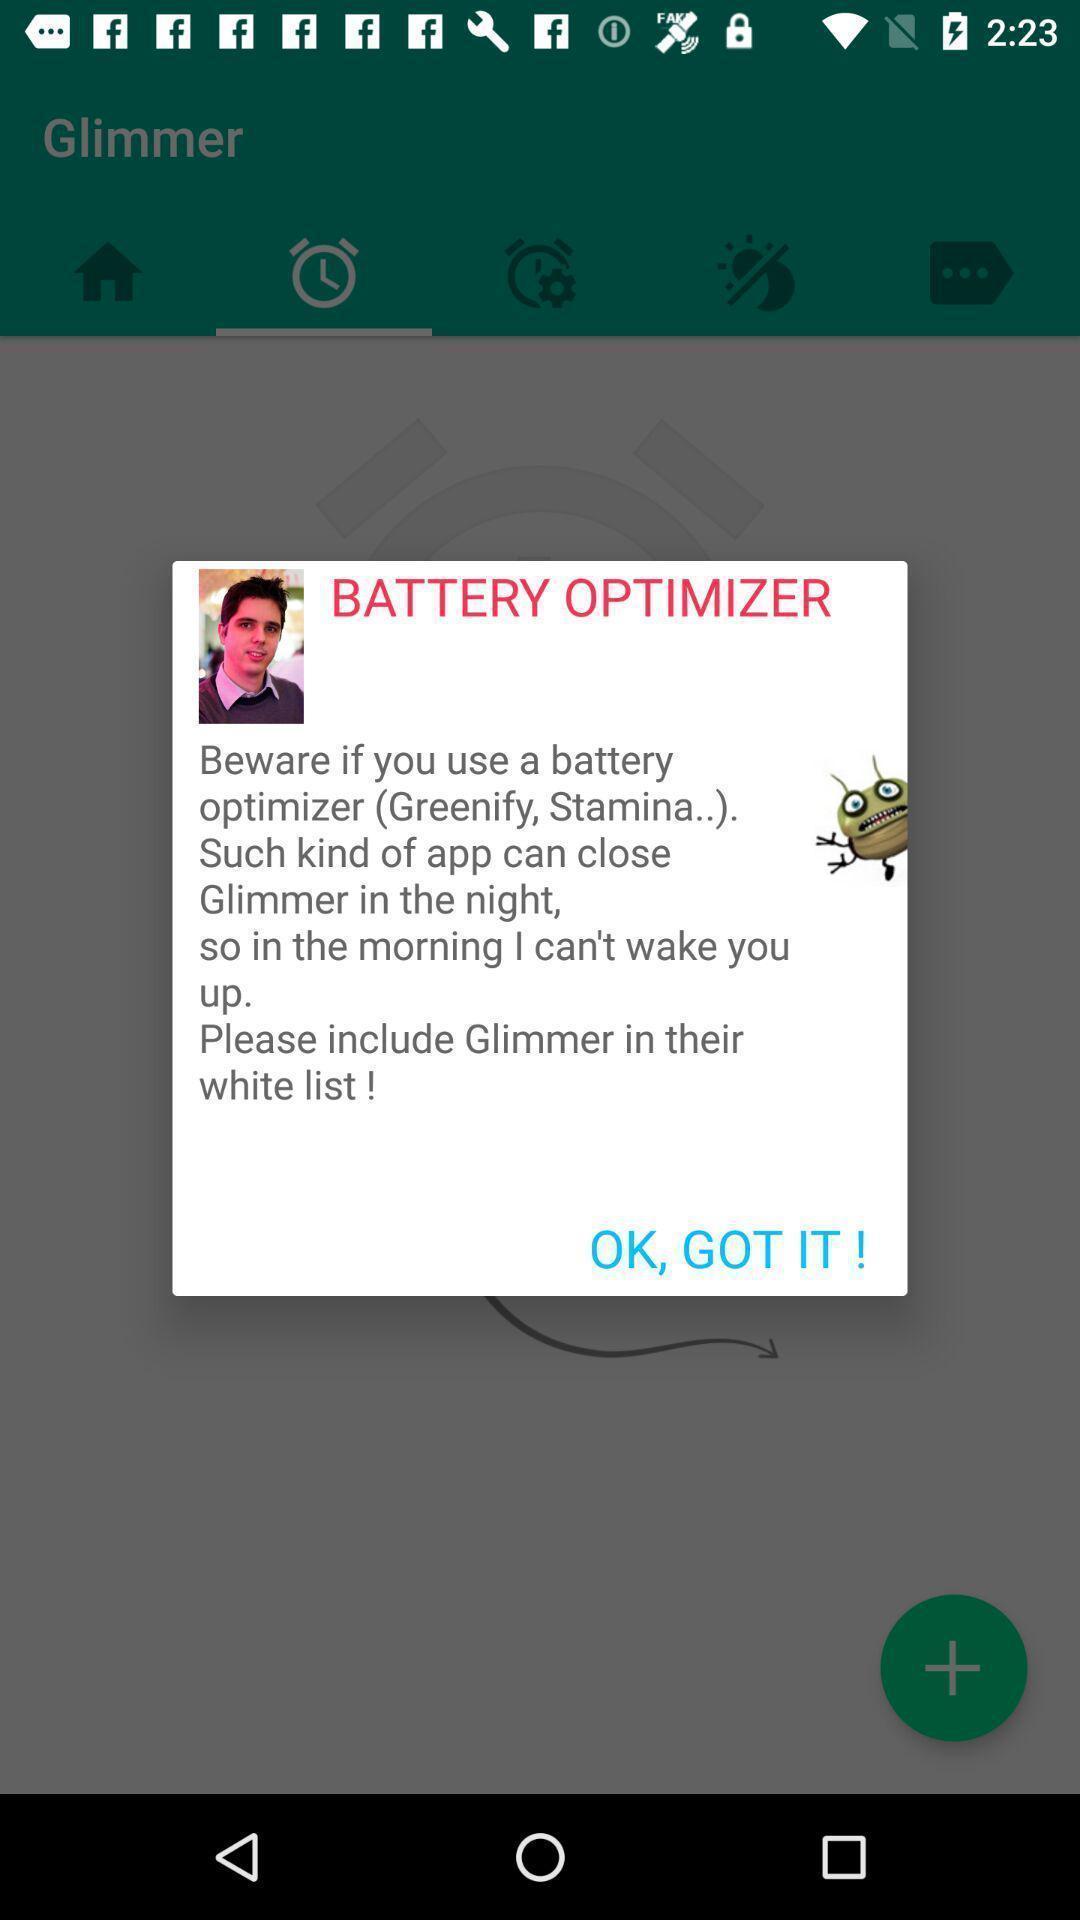What can you discern from this picture? Popup of description regarding battery in the application. 